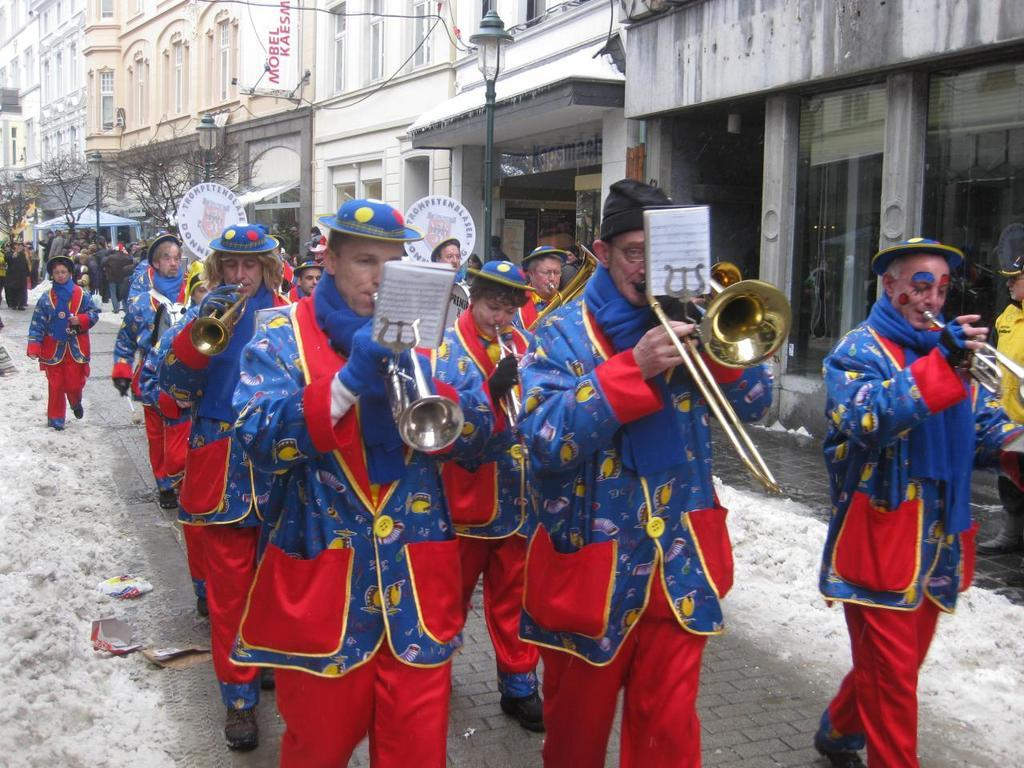What are the people in the image doing? The people in the image are standing and holding musical instruments. What can be seen in the background of the image? There are trees and buildings in the background of the image. What is the condition of the ground in the image? The ground has snow on it. Can you see a donkey wearing a crown in the image? No, there is no donkey or crown present in the image. What type of rake is being used by the people in the image? There is no rake visible in the image; the people are holding musical instruments. 